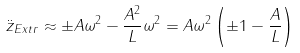<formula> <loc_0><loc_0><loc_500><loc_500>\ddot { z } _ { E x t r } \approx \pm A \omega ^ { 2 } - \frac { A ^ { 2 } } { L } \omega ^ { 2 } = A \omega ^ { 2 } \left ( \pm 1 - \frac { A } { L } \right )</formula> 